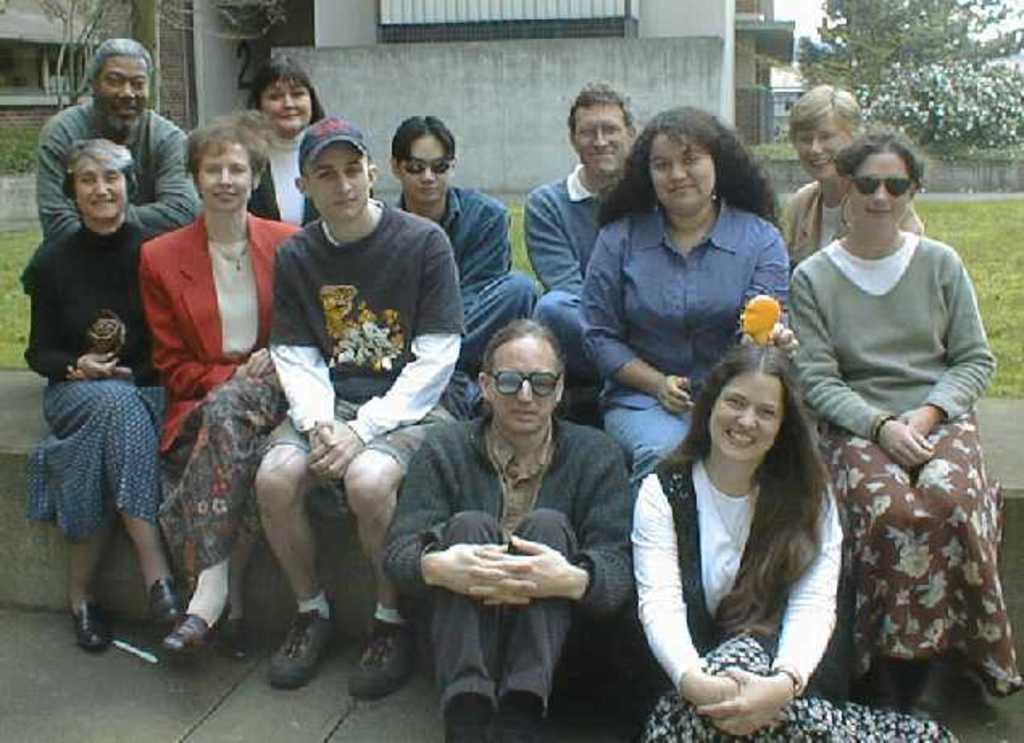Could you give a brief overview of what you see in this image? In the foreground of the image there are people sitting. In the background of the image there are houses, trees, grass. At the bottom of the image there is floor. 